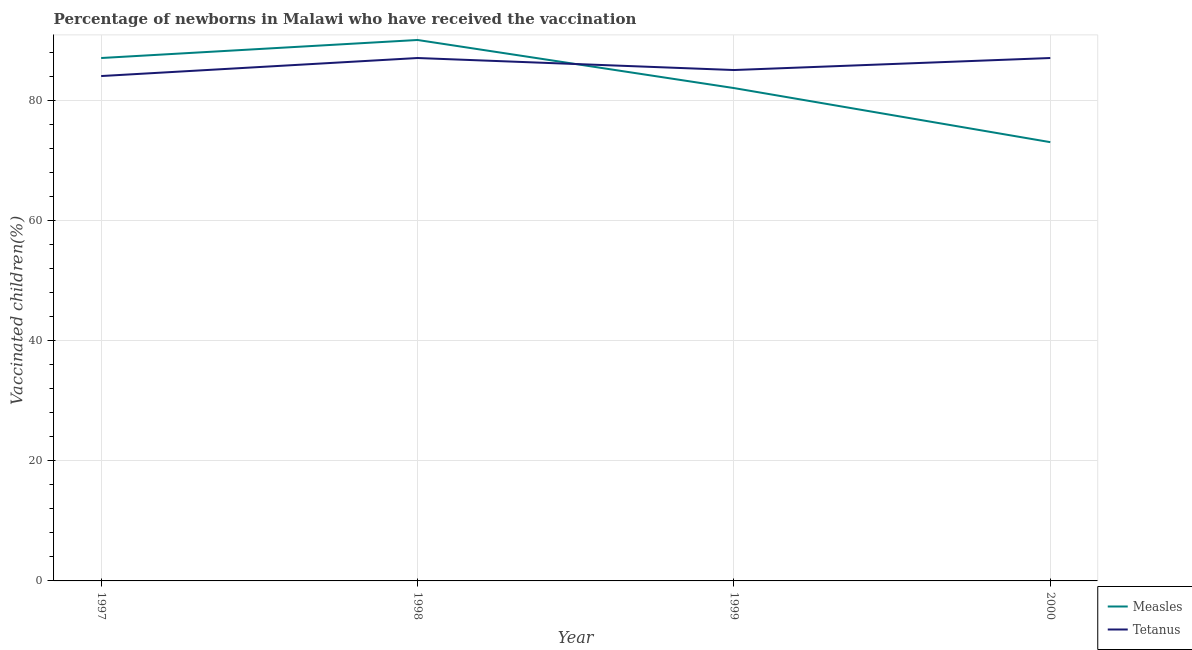What is the percentage of newborns who received vaccination for tetanus in 1997?
Your answer should be compact. 84. Across all years, what is the maximum percentage of newborns who received vaccination for tetanus?
Offer a terse response. 87. Across all years, what is the minimum percentage of newborns who received vaccination for measles?
Give a very brief answer. 73. In which year was the percentage of newborns who received vaccination for measles maximum?
Ensure brevity in your answer.  1998. In which year was the percentage of newborns who received vaccination for measles minimum?
Provide a succinct answer. 2000. What is the total percentage of newborns who received vaccination for measles in the graph?
Your answer should be compact. 332. What is the difference between the percentage of newborns who received vaccination for tetanus in 1997 and that in 2000?
Ensure brevity in your answer.  -3. What is the difference between the percentage of newborns who received vaccination for tetanus in 1997 and the percentage of newborns who received vaccination for measles in 1999?
Make the answer very short. 2. In the year 2000, what is the difference between the percentage of newborns who received vaccination for measles and percentage of newborns who received vaccination for tetanus?
Offer a very short reply. -14. What is the ratio of the percentage of newborns who received vaccination for measles in 1998 to that in 2000?
Make the answer very short. 1.23. Is the difference between the percentage of newborns who received vaccination for tetanus in 1997 and 1998 greater than the difference between the percentage of newborns who received vaccination for measles in 1997 and 1998?
Offer a very short reply. No. What is the difference between the highest and the lowest percentage of newborns who received vaccination for measles?
Provide a succinct answer. 17. In how many years, is the percentage of newborns who received vaccination for measles greater than the average percentage of newborns who received vaccination for measles taken over all years?
Offer a terse response. 2. Does the percentage of newborns who received vaccination for measles monotonically increase over the years?
Ensure brevity in your answer.  No. Is the percentage of newborns who received vaccination for measles strictly less than the percentage of newborns who received vaccination for tetanus over the years?
Give a very brief answer. No. How many lines are there?
Keep it short and to the point. 2. How many years are there in the graph?
Your response must be concise. 4. What is the difference between two consecutive major ticks on the Y-axis?
Provide a short and direct response. 20. Are the values on the major ticks of Y-axis written in scientific E-notation?
Your answer should be very brief. No. Does the graph contain grids?
Make the answer very short. Yes. Where does the legend appear in the graph?
Your response must be concise. Bottom right. How many legend labels are there?
Offer a terse response. 2. What is the title of the graph?
Make the answer very short. Percentage of newborns in Malawi who have received the vaccination. Does "Female population" appear as one of the legend labels in the graph?
Give a very brief answer. No. What is the label or title of the Y-axis?
Give a very brief answer. Vaccinated children(%)
. What is the Vaccinated children(%)
 in Measles in 1997?
Give a very brief answer. 87. What is the Vaccinated children(%)
 of Measles in 1998?
Provide a short and direct response. 90. What is the Vaccinated children(%)
 of Tetanus in 1999?
Offer a terse response. 85. What is the Vaccinated children(%)
 of Measles in 2000?
Make the answer very short. 73. What is the Vaccinated children(%)
 of Tetanus in 2000?
Make the answer very short. 87. Across all years, what is the minimum Vaccinated children(%)
 in Tetanus?
Provide a short and direct response. 84. What is the total Vaccinated children(%)
 of Measles in the graph?
Give a very brief answer. 332. What is the total Vaccinated children(%)
 in Tetanus in the graph?
Offer a very short reply. 343. What is the difference between the Vaccinated children(%)
 in Tetanus in 1997 and that in 1998?
Provide a short and direct response. -3. What is the difference between the Vaccinated children(%)
 of Measles in 1997 and that in 2000?
Offer a terse response. 14. What is the difference between the Vaccinated children(%)
 in Measles in 1998 and that in 1999?
Provide a succinct answer. 8. What is the difference between the Vaccinated children(%)
 of Tetanus in 1998 and that in 1999?
Offer a terse response. 2. What is the difference between the Vaccinated children(%)
 of Tetanus in 1998 and that in 2000?
Keep it short and to the point. 0. What is the difference between the Vaccinated children(%)
 in Tetanus in 1999 and that in 2000?
Provide a succinct answer. -2. What is the difference between the Vaccinated children(%)
 in Measles in 1998 and the Vaccinated children(%)
 in Tetanus in 1999?
Keep it short and to the point. 5. What is the difference between the Vaccinated children(%)
 of Measles in 1999 and the Vaccinated children(%)
 of Tetanus in 2000?
Provide a succinct answer. -5. What is the average Vaccinated children(%)
 of Measles per year?
Make the answer very short. 83. What is the average Vaccinated children(%)
 of Tetanus per year?
Provide a short and direct response. 85.75. In the year 1997, what is the difference between the Vaccinated children(%)
 of Measles and Vaccinated children(%)
 of Tetanus?
Make the answer very short. 3. In the year 1999, what is the difference between the Vaccinated children(%)
 in Measles and Vaccinated children(%)
 in Tetanus?
Provide a succinct answer. -3. What is the ratio of the Vaccinated children(%)
 in Measles in 1997 to that in 1998?
Your answer should be compact. 0.97. What is the ratio of the Vaccinated children(%)
 of Tetanus in 1997 to that in 1998?
Ensure brevity in your answer.  0.97. What is the ratio of the Vaccinated children(%)
 of Measles in 1997 to that in 1999?
Your answer should be compact. 1.06. What is the ratio of the Vaccinated children(%)
 of Tetanus in 1997 to that in 1999?
Your answer should be compact. 0.99. What is the ratio of the Vaccinated children(%)
 in Measles in 1997 to that in 2000?
Offer a very short reply. 1.19. What is the ratio of the Vaccinated children(%)
 of Tetanus in 1997 to that in 2000?
Your answer should be compact. 0.97. What is the ratio of the Vaccinated children(%)
 in Measles in 1998 to that in 1999?
Offer a very short reply. 1.1. What is the ratio of the Vaccinated children(%)
 of Tetanus in 1998 to that in 1999?
Ensure brevity in your answer.  1.02. What is the ratio of the Vaccinated children(%)
 of Measles in 1998 to that in 2000?
Make the answer very short. 1.23. What is the ratio of the Vaccinated children(%)
 in Tetanus in 1998 to that in 2000?
Your answer should be very brief. 1. What is the ratio of the Vaccinated children(%)
 of Measles in 1999 to that in 2000?
Your answer should be compact. 1.12. What is the ratio of the Vaccinated children(%)
 of Tetanus in 1999 to that in 2000?
Your answer should be compact. 0.98. What is the difference between the highest and the second highest Vaccinated children(%)
 of Tetanus?
Offer a terse response. 0. What is the difference between the highest and the lowest Vaccinated children(%)
 of Tetanus?
Provide a succinct answer. 3. 